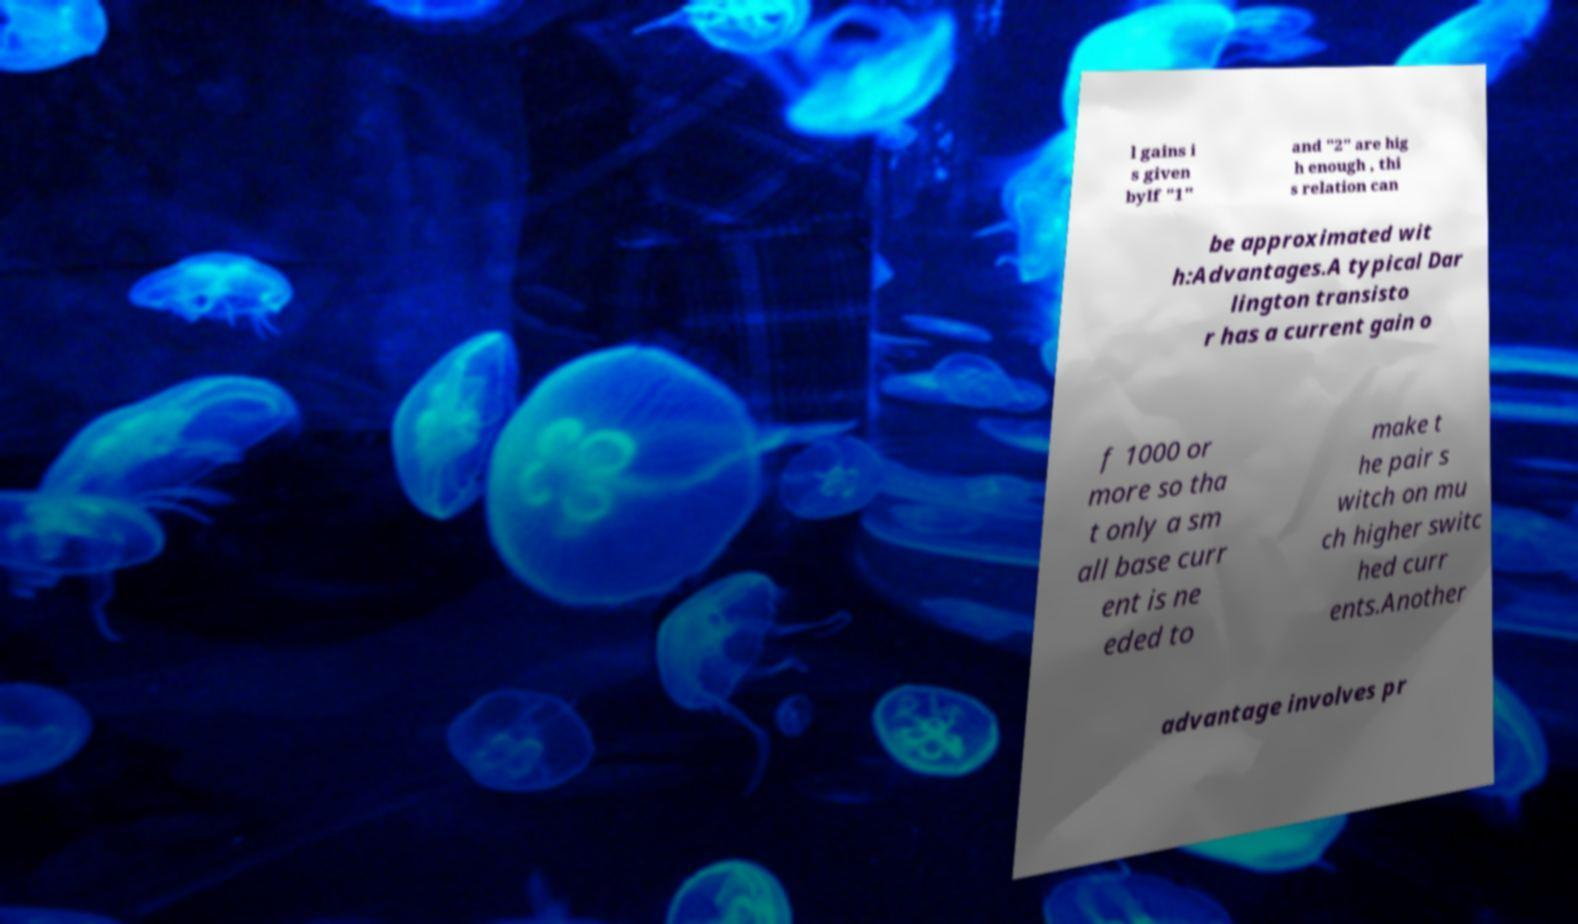What messages or text are displayed in this image? I need them in a readable, typed format. l gains i s given byIf "1" and "2" are hig h enough , thi s relation can be approximated wit h:Advantages.A typical Dar lington transisto r has a current gain o f 1000 or more so tha t only a sm all base curr ent is ne eded to make t he pair s witch on mu ch higher switc hed curr ents.Another advantage involves pr 